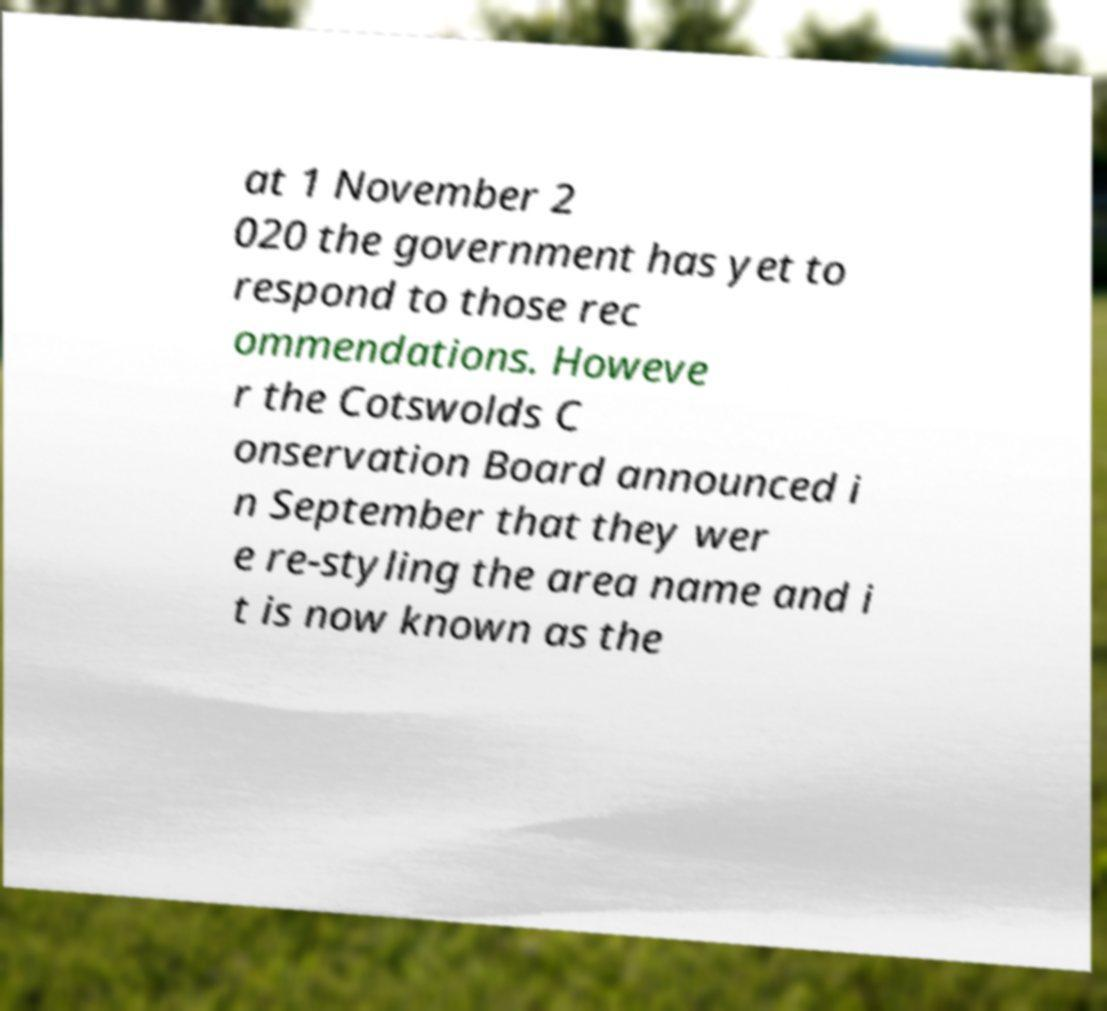Please read and relay the text visible in this image. What does it say? at 1 November 2 020 the government has yet to respond to those rec ommendations. Howeve r the Cotswolds C onservation Board announced i n September that they wer e re-styling the area name and i t is now known as the 